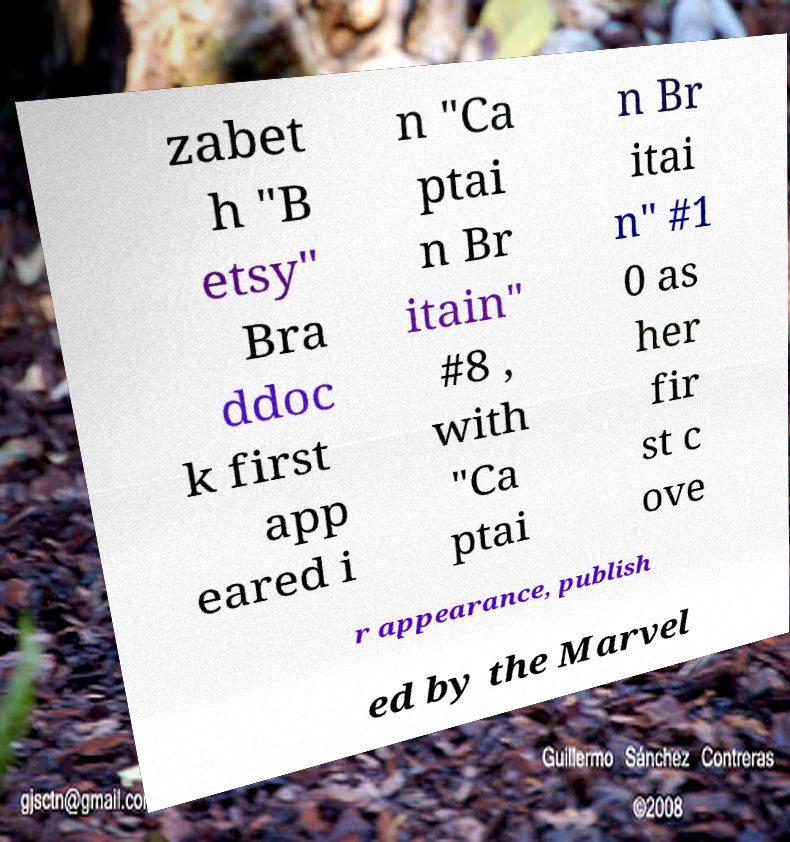Please identify and transcribe the text found in this image. zabet h "B etsy" Bra ddoc k first app eared i n "Ca ptai n Br itain" #8 , with "Ca ptai n Br itai n" #1 0 as her fir st c ove r appearance, publish ed by the Marvel 